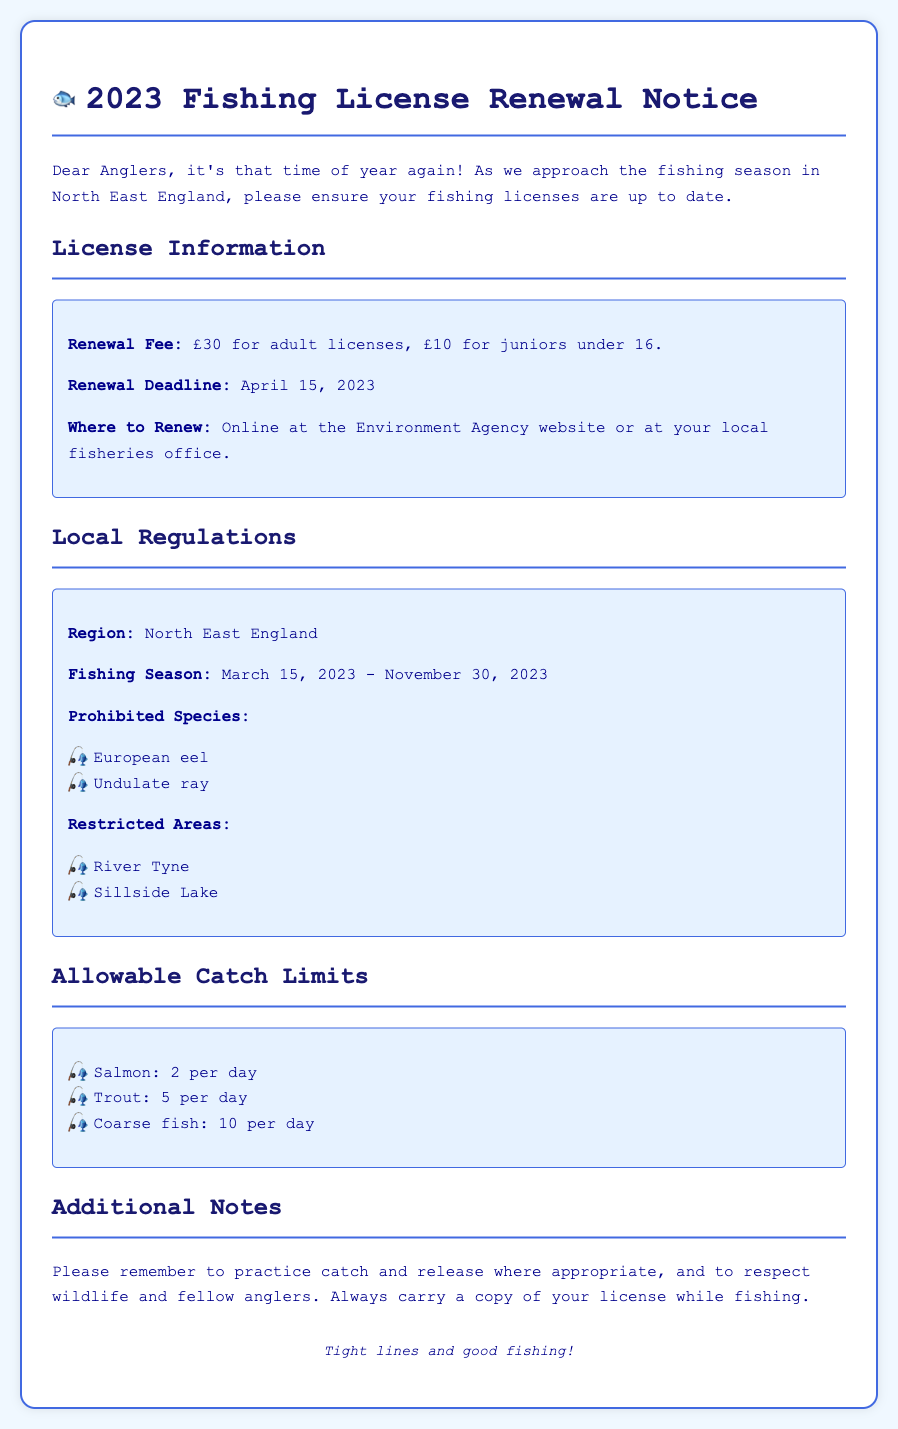What is the renewal fee for adult licenses? The renewal fee for adult licenses is clearly stated in the document as £30.
Answer: £30 What is the renewal deadline? The renewal deadline is specified in the document as April 15, 2023.
Answer: April 15, 2023 Which two species are prohibited? The document lists the prohibited species as European eel and Undulate ray.
Answer: European eel, Undulate ray What is the fishing season? The fishing season is indicated in the document as March 15, 2023 - November 30, 2023.
Answer: March 15, 2023 - November 30, 2023 How many salmon can be caught per day? The allowable catch limit for salmon is provided, which is 2 per day.
Answer: 2 per day Where can licenses be renewed? The document states licenses can be renewed online at the Environment Agency website or at the local fisheries office.
Answer: Online at the Environment Agency website or at your local fisheries office Name one restricted area for fishing. The document mentions two restricted areas, one of which is River Tyne.
Answer: River Tyne What is the juvenile renewal fee? The renewal fee for juniors under 16 is listed as £10.
Answer: £10 What is the document type? The document type is described as a Fishing License Renewal Notice for the year 2023.
Answer: Fishing License Renewal Notice 